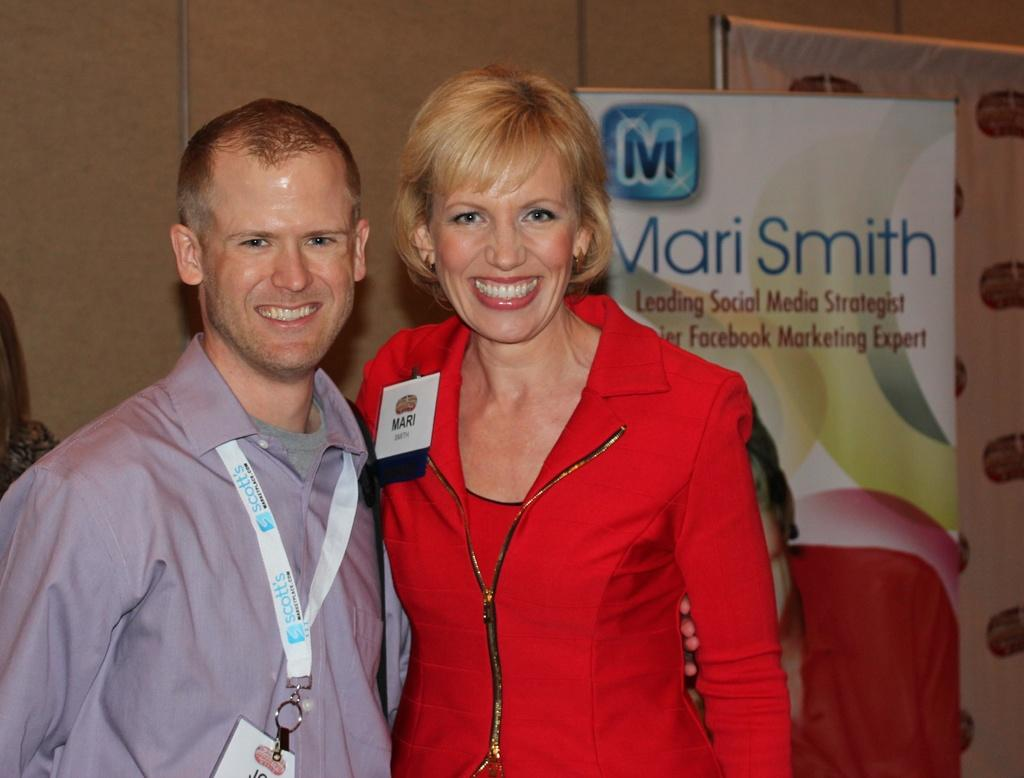How many people are present in the image? There are two persons standing in the image. What are the persons standing on? The persons are standing on the floor and posters. Can you describe the background of the image? There is a person visible in the background of the image, and there is a wall in the background as well. What type of location might the image have been taken in? The image may have been taken in a hall, based on the presence of posters and the wall. What type of pencil is being used by the person in the image? There is no pencil visible in the image; the persons are standing on the floor and posters. 